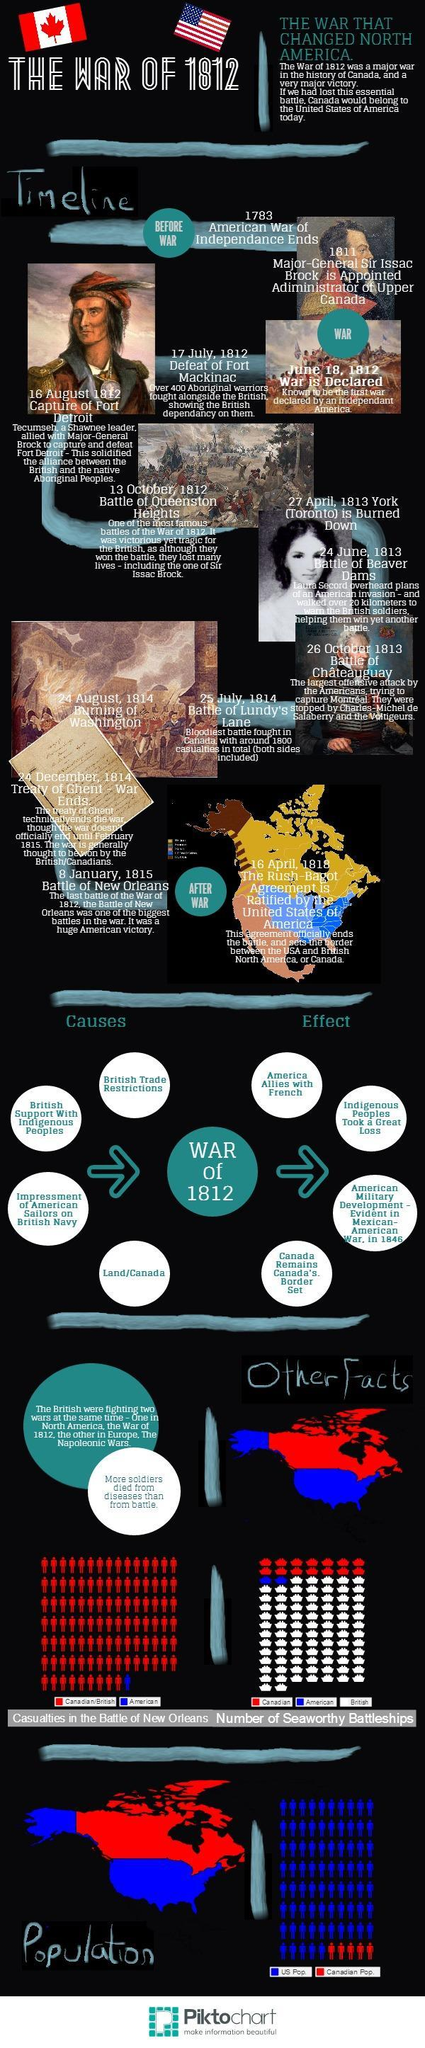When was Toronto burnt down?
Answer the question with a short phrase. 27 April, 1813 Which two wars were the British fighting at the same time? The War of 1812, the napoleonic wars When was the battle of Beaver Dams? 24 June, 1813 Who were allies with the Americans during the war of 1812? French Who had more casualties in the battle of New Orleans, Americans or British? British When was the battle of New Orleans? 8 January, 1815 What were the casualties in the battle of Lundy's lane (approx)? 1800 Who were impressed into the British Navy? American sailors When was Fort Detroit captured? 16 August, 1812 When was the Rush Bagot agreement ratified? 16 April, 1818 When was the burning of Washington? 24 August, 1814 What was Toronto's previous name? York When was Isaac Brock appointed as the administrator of upper Canada? 1811 Who helped the Britishers win the battle of Beaver Dams? Laura Secord Which was the bloodiest battle fought in Canada? Battle of Lundy's lane How many "causes" of the war are mentioned? 4 What did majority of the soldiers die of? Disease Who had the highest number of seaworthy battleships? British When did the American war of independence end? 1783 When was the war declared? June 18, 1812 